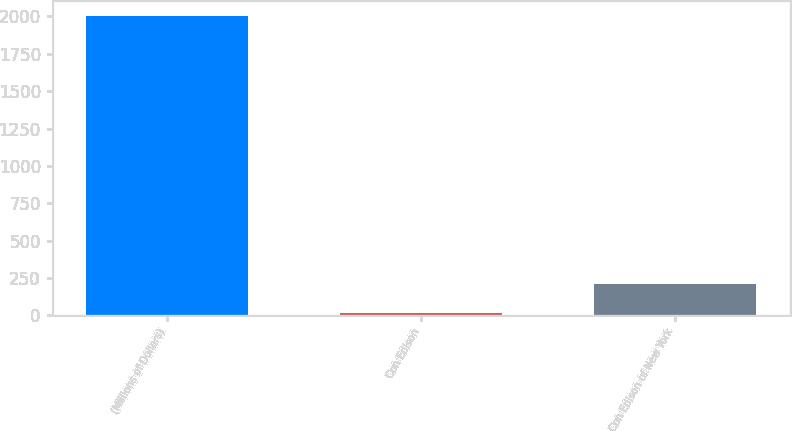Convert chart. <chart><loc_0><loc_0><loc_500><loc_500><bar_chart><fcel>(Millions of Dollars)<fcel>Con Edison<fcel>Con Edison of New York<nl><fcel>2005<fcel>14<fcel>213.1<nl></chart> 